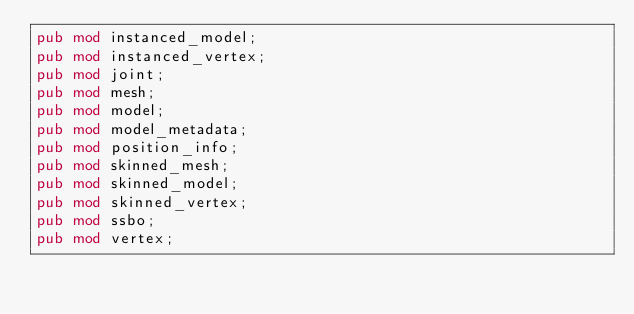Convert code to text. <code><loc_0><loc_0><loc_500><loc_500><_Rust_>pub mod instanced_model;
pub mod instanced_vertex;
pub mod joint;
pub mod mesh;
pub mod model;
pub mod model_metadata;
pub mod position_info;
pub mod skinned_mesh;
pub mod skinned_model;
pub mod skinned_vertex;
pub mod ssbo;
pub mod vertex;
</code> 